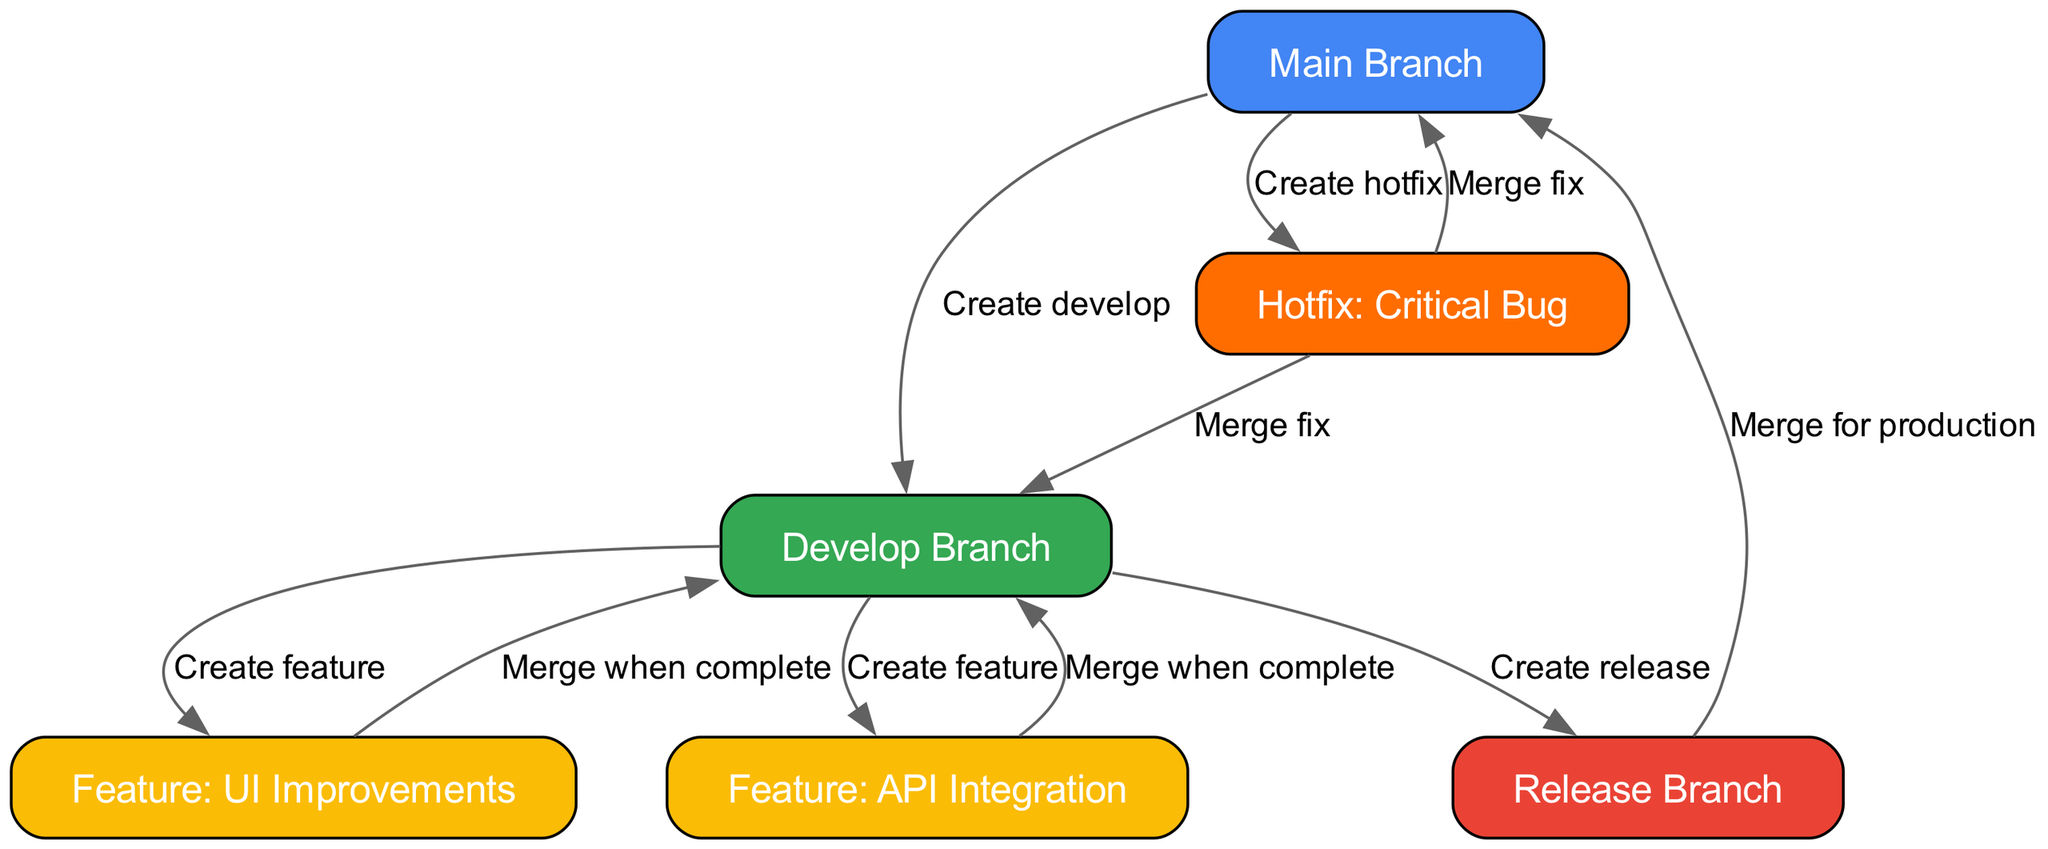What are the main branches in the diagram? The main branches in the diagram are "Main Branch" and "Develop Branch." I can identify these because they are the first two nodes connected at the top of the diagram.
Answer: Main Branch, Develop Branch How many feature branches are created from the develop branch? There are two feature branches created from the develop branch: "Feature: UI Improvements" and "Feature: API Integration." This is evident as there are two edges going from the develop node to the feature nodes.
Answer: 2 What is the relationship between the release branch and the main branch? The relationship is that the "Release Branch" merges into the "Main Branch" for production. This is shown by the directed edge pointing from release to main, labeled "Merge for production."
Answer: Merge for production Which branch allows for creating a hotfix? The "Main Branch" allows for creating a hotfix, as indicated by the directed edge from main to hotfix, which is labeled "Create hotfix."
Answer: Main Branch What happens after a feature branch is complete? After a feature branch is complete, it merges back into the develop branch. This is evidenced by the edges labeled "Merge when complete" pointing from both feature branches to the develop branch.
Answer: Merge back to develop What is the purpose of the hotfix branch in the branching strategy? The purpose of the hotfix branch is to address critical bugs. This is indicated by the label of the node as "Hotfix: Critical Bug" and the edges showing the merge actions after creating the hotfix.
Answer: Address critical bugs How many edges are there in total? There are a total of ten edges in the diagram, which connect various branches and their relationships. This can be counted directly from the edges listed in the data.
Answer: 10 Which branch is created first in the strategy? The first branch created in the strategy is the "Develop Branch," which is created from the "Main Branch," as indicated by the directed edge labeled "Create develop."
Answer: Develop Branch What merges into the main branch after a release? After a release, the "Release Branch" merges into the "Main Branch." This is confirmed by the directed edge from release to main labeled "Merge for production."
Answer: Release Branch 